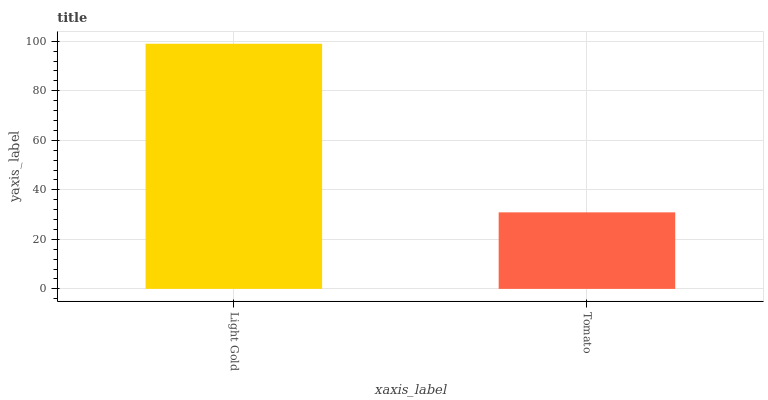Is Tomato the minimum?
Answer yes or no. Yes. Is Light Gold the maximum?
Answer yes or no. Yes. Is Tomato the maximum?
Answer yes or no. No. Is Light Gold greater than Tomato?
Answer yes or no. Yes. Is Tomato less than Light Gold?
Answer yes or no. Yes. Is Tomato greater than Light Gold?
Answer yes or no. No. Is Light Gold less than Tomato?
Answer yes or no. No. Is Light Gold the high median?
Answer yes or no. Yes. Is Tomato the low median?
Answer yes or no. Yes. Is Tomato the high median?
Answer yes or no. No. Is Light Gold the low median?
Answer yes or no. No. 